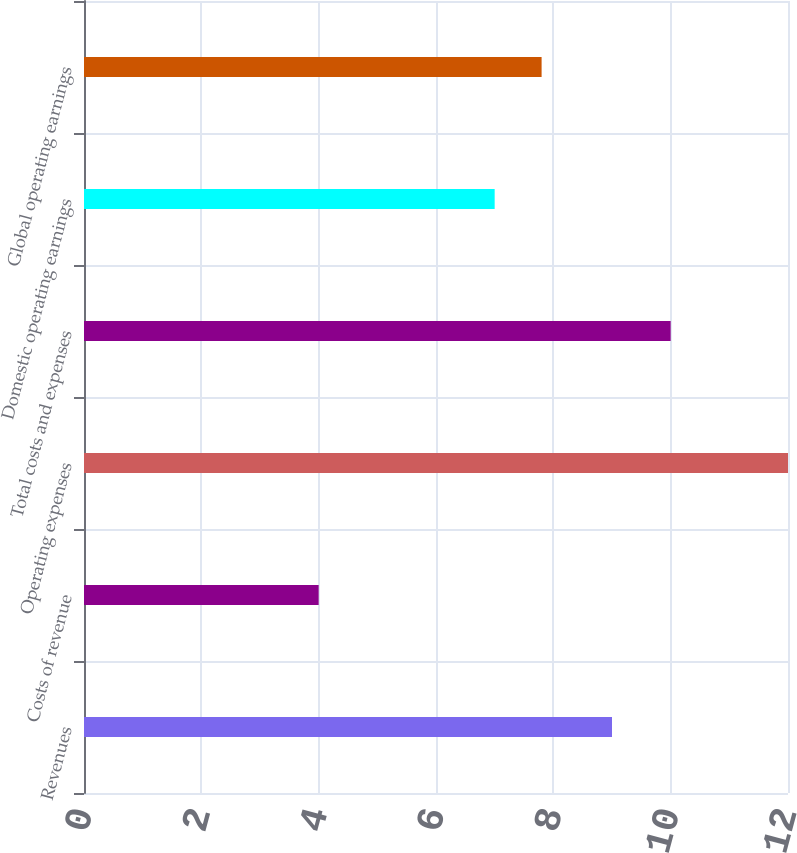<chart> <loc_0><loc_0><loc_500><loc_500><bar_chart><fcel>Revenues<fcel>Costs of revenue<fcel>Operating expenses<fcel>Total costs and expenses<fcel>Domestic operating earnings<fcel>Global operating earnings<nl><fcel>9<fcel>4<fcel>12<fcel>10<fcel>7<fcel>7.8<nl></chart> 